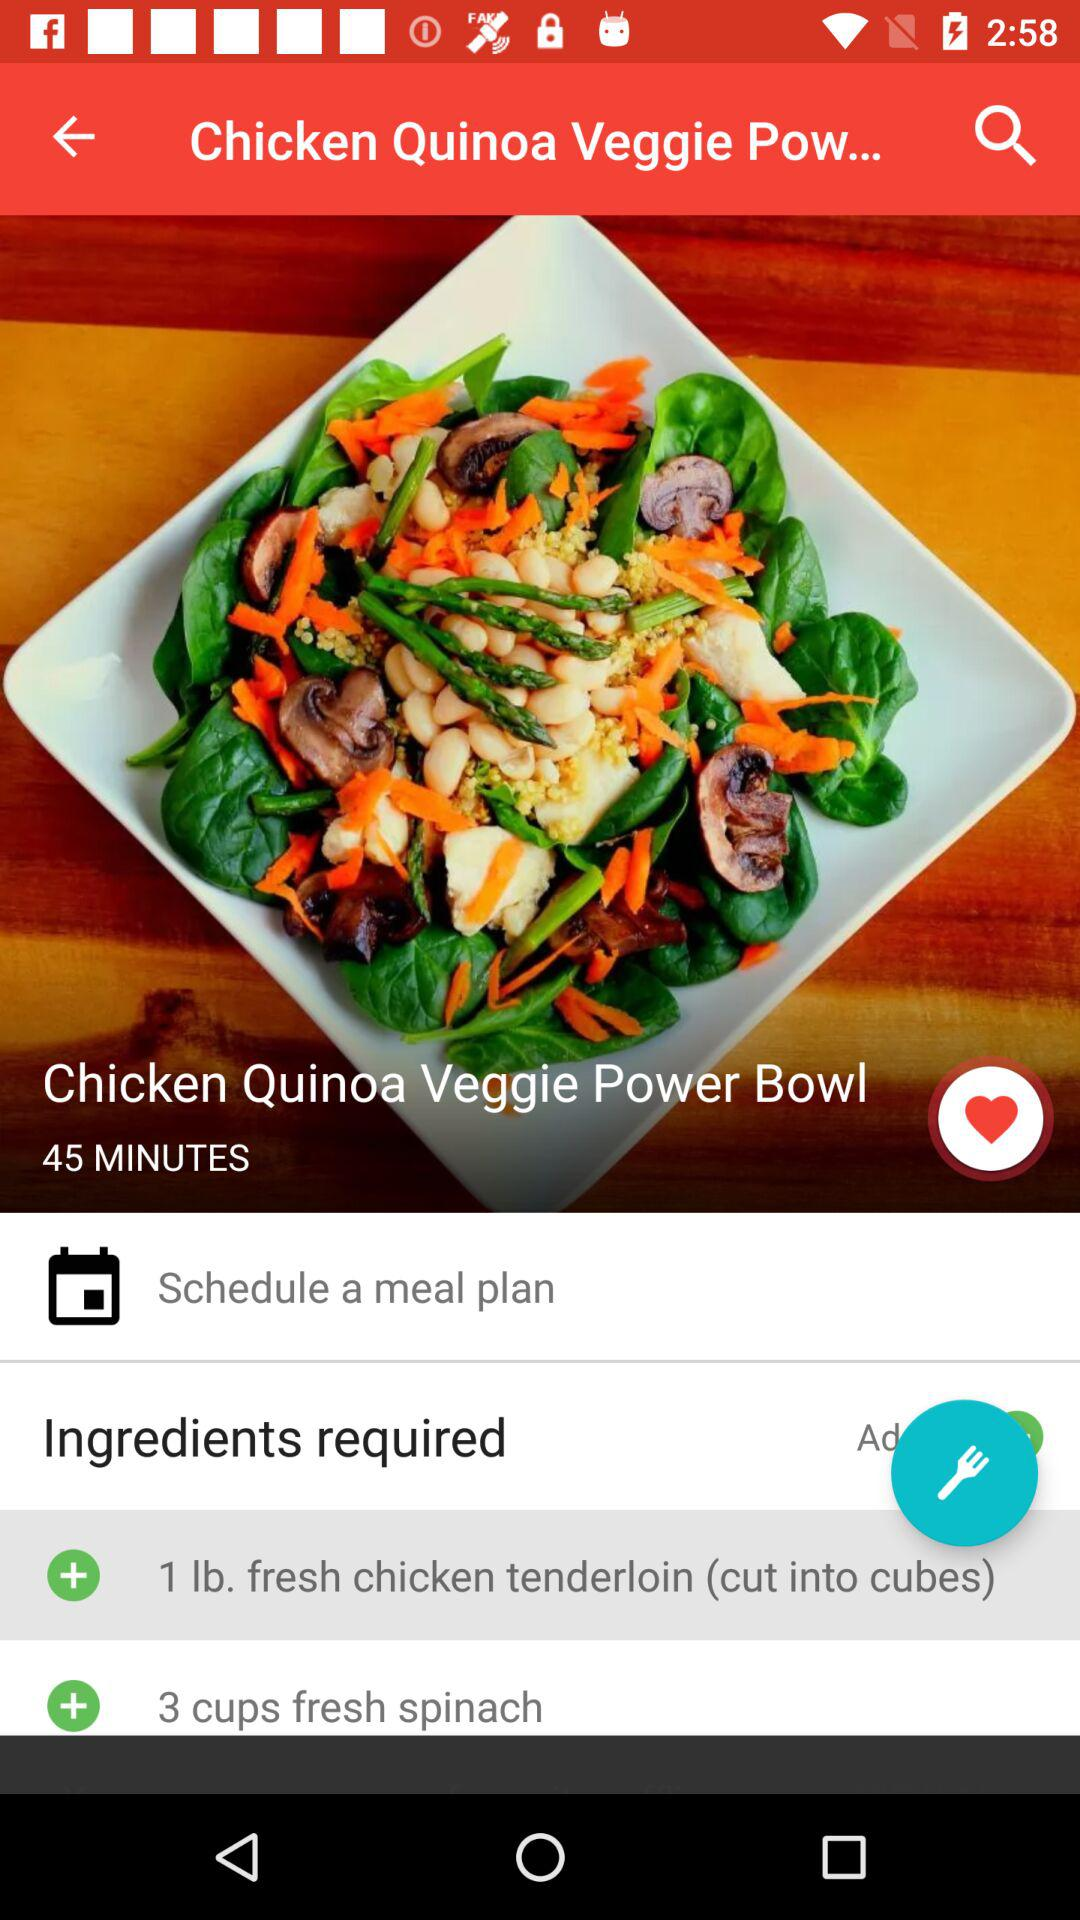What are the ingredients required for the recipe? The ingredients required are "1 lb. fresh chicken tenderloin" and "3 cups fresh spinach". 